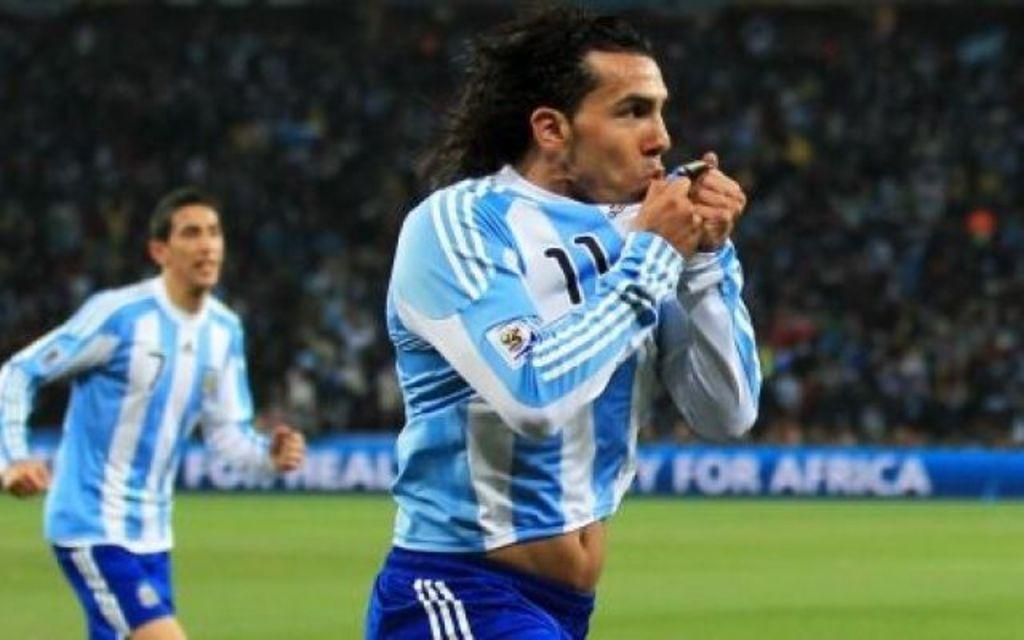How many people are in the foreground of the image? There are two persons in the foreground of the image. What can be seen in the background of the image? There are people in stands in the background of the image. What type of terrain is visible at the bottom of the image? There is grass visible at the bottom of the image. What type of comb is being used by the person in the image? There is no comb present in the image. 